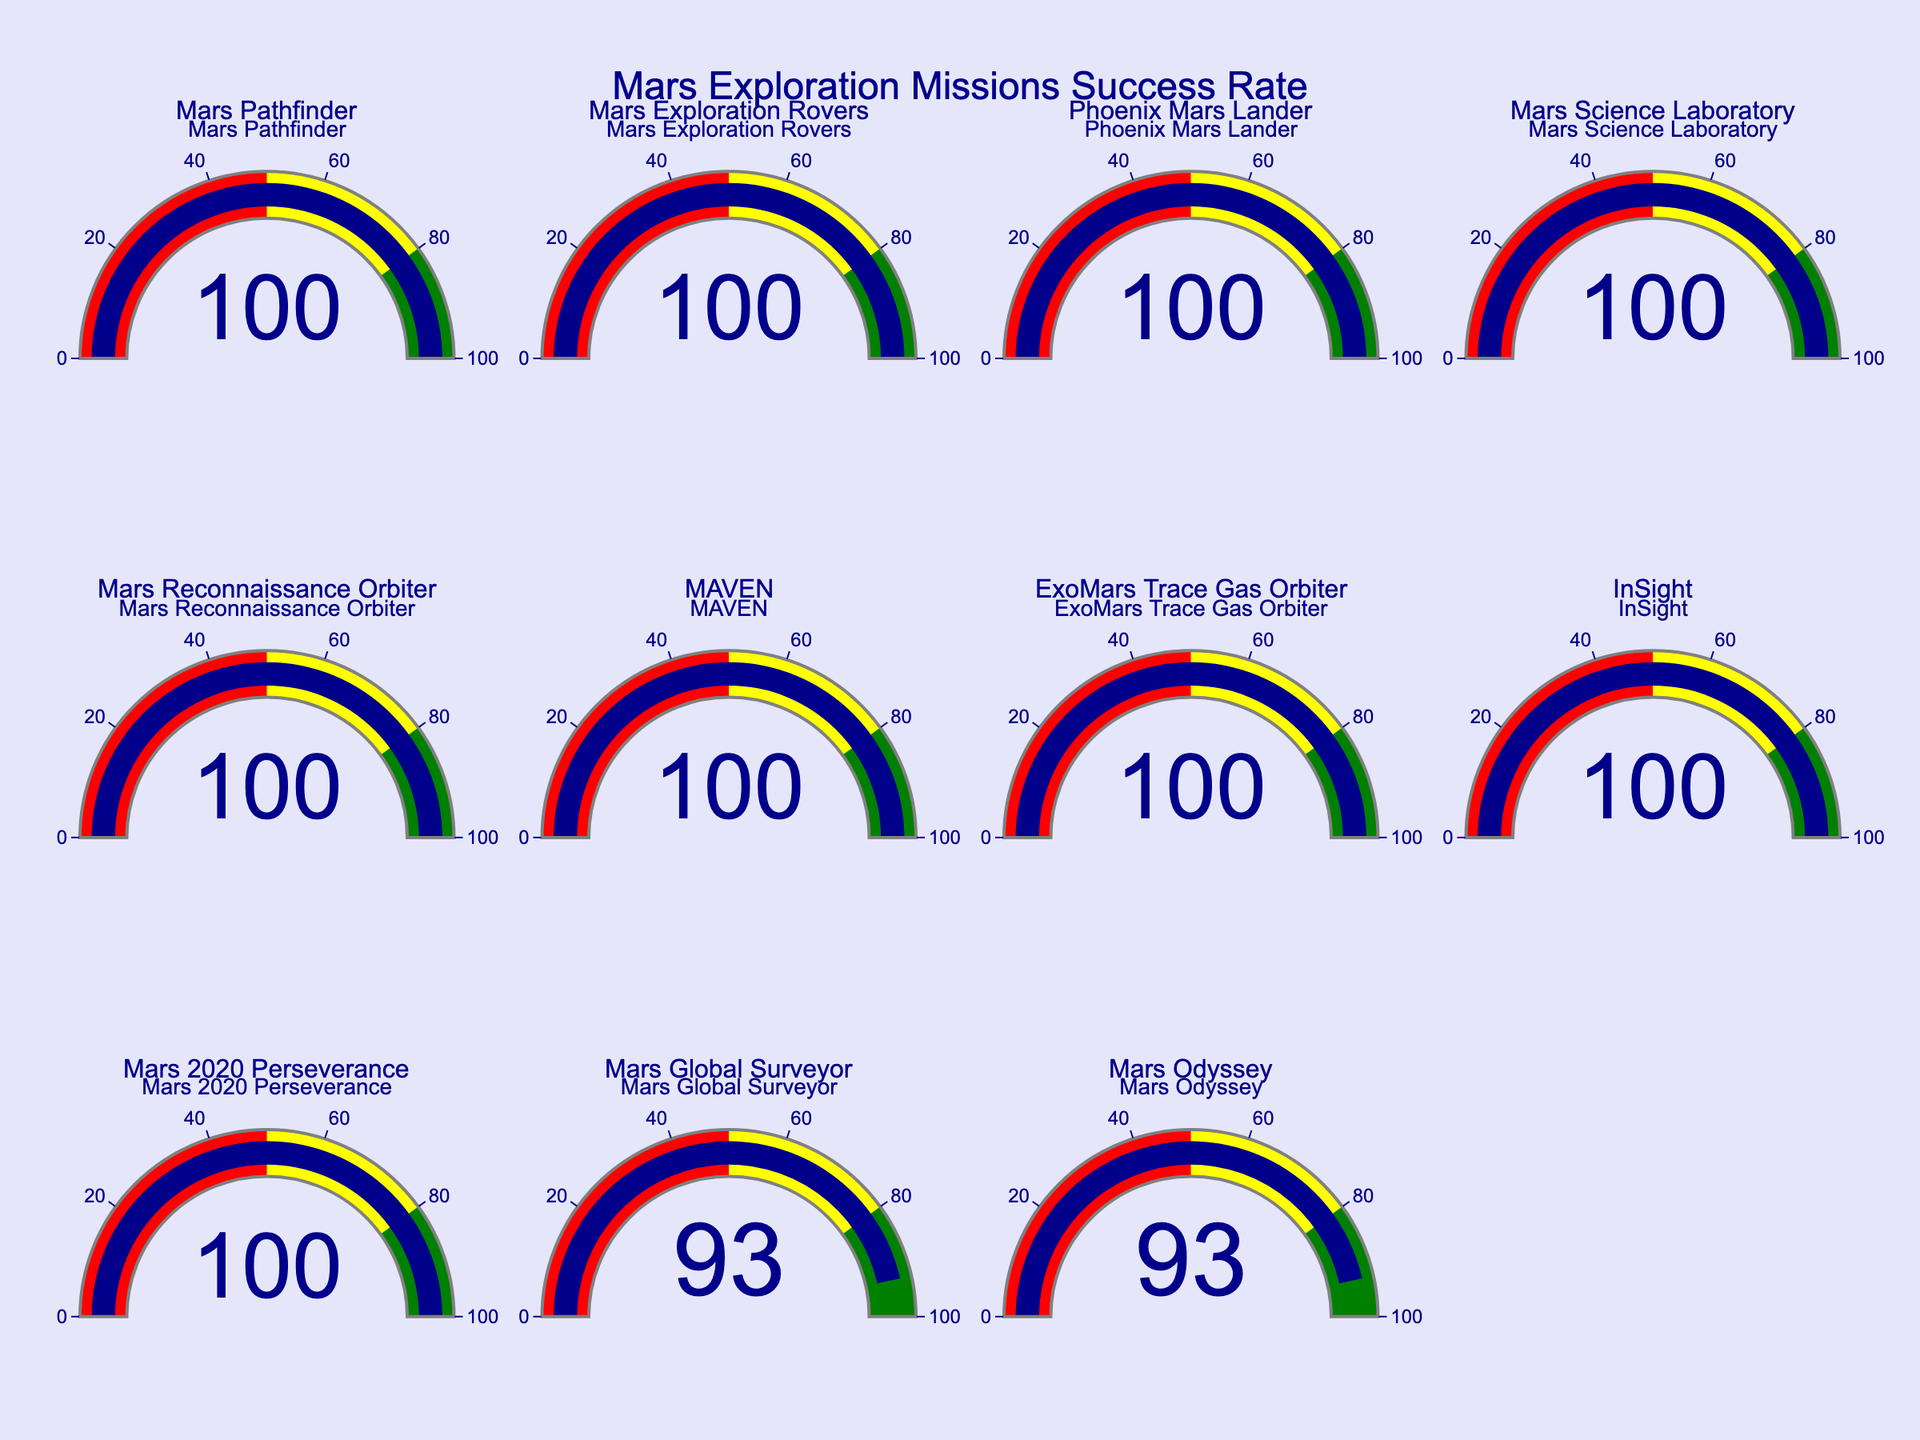What is the success rate of the Mars Pathfinder mission? The gauge chart for the Mars Pathfinder mission shows the success rate number directly on the gauge.
Answer: 100 Which mission has the lowest success rate displayed in the figure? By examining all the gauges, the Mars Global Surveyor and Mars Odyssey both show the lowest success rate.
Answer: Mars Global Surveyor, Mars Odyssey What is the average success rate of the Mars missions with a rate of 93%? Only Mars Global Surveyor and Mars Odyssey have rates of 93%. Therefore, the average is (93 + 93) / 2.
Answer: 93 Between the Mars Science Laboratory and the InSight mission, which one has a higher success rate? Both the Mars Science Laboratory and the InSight mission show a success rate of 100%, so neither is higher.
Answer: Neither How many missions have a 100% success rate? By counting the gauges showing 100%, there are 9 missions with this success rate.
Answer: 9 What's the median mission success rate in the figure? Arrange the success rates in order: 93, 93, 100, 100, 100, 100, 100, 100, 100, 100, 100. The middle value (6th in this case) is 100.
Answer: 100 If a new mission is added with a success rate of 85%, what would the new average success rate be? First calculate the current average (95% across 11 missions: (900 + 186) / 11 = 98.18). Adding a mission with 85%: (985 + 85) / 12 = 1070 / 12.
Answer: 89.17 Which color coding does the gauge use to represent success rates ranging from 0 to 50? The color bands on the gauges indicate red for the 0 to 50 range.
Answer: Red What title is displayed at the top of the figure? The title is shown prominently at the top of the figure.
Answer: Mars Exploration Missions Success Rate If all missions had a success rate of 75%, what color would be predominant on the figure? The color coding for the success rate range of 50 to 80 is yellow.
Answer: Yellow 